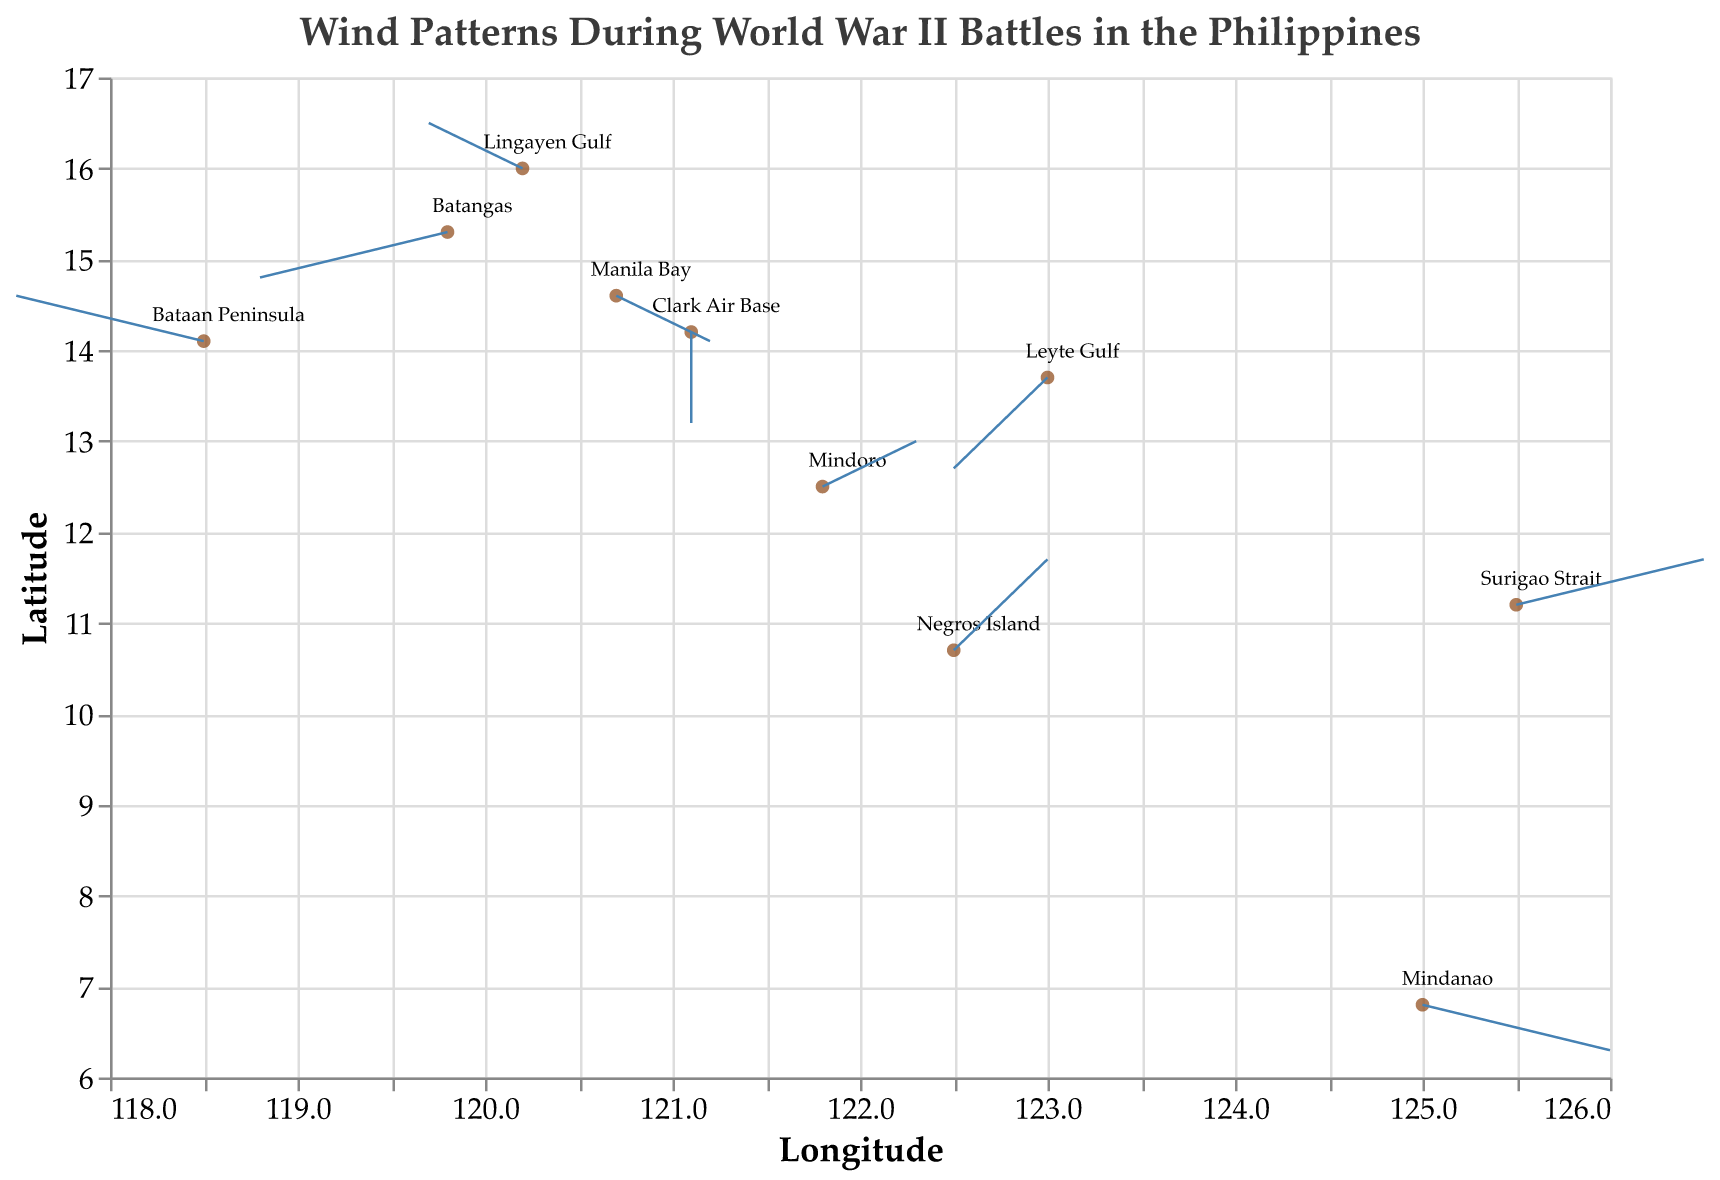What is the title of the figure? The title of the figure is displayed prominently at the top, indicating what the plot represents.
Answer: Wind Patterns During World War II Battles in the Philippines How many battles are represented in the plot? There are a total of 10 data points, each representing a different battle during World War II in the Philippines.
Answer: 10 Which location shows wind blowing directly downward? Look for a location where the vector (arrow) is pointing straight downwards. In the figure, Clark Air Base has a wind vector with U=0 and V=-2, indicating straight downward wind.
Answer: Clark Air Base Compare the wind direction at Bataan Peninsula and Manila Bay. Which location has the wind blowing towards the southeast? Examine the direction of the arrows for both locations. Bataan Peninsula’s wind blows to the southwest, while Manila Bay’s wind blows southeastward (U=1, V=-1). Hence, Manila Bay has wind blowing toward the southeast.
Answer: Manila Bay What is the direction and magnitude of the wind at Batangas? Check the U and V components for Batangas. The arrows show U=-2 and V=-1, meaning wind is blowing southwest with a magnitude calculated as sqrt((-2)^2 + (-1)^2) ≈ 2.24.
Answer: Southwest, magnitude ≈ 2.24 Which location has the wind with the highest positive U component, and what is its value? Identify the largest positive U value from the data. Surigao Strait and Mindanao have U=2, which is the highest positive value.
Answer: Surigao Strait and Mindanao, value=2 Are there any locations where the wind vectors have only horizontal or vertical components? Look for vectors where either U=0 or V=0. Clark Air Base has U=0, indicating vertical-only wind direction.
Answer: Yes, Clark Air Base Which location has the wind blowing towards the northwest and with what components? Identify vectors with negative U and positive V components. Bataan Peninsula shows wind with U=-2, V=1, indicating wind blowing northwestward.
Answer: Bataan Peninsula, U=-2, V=1 